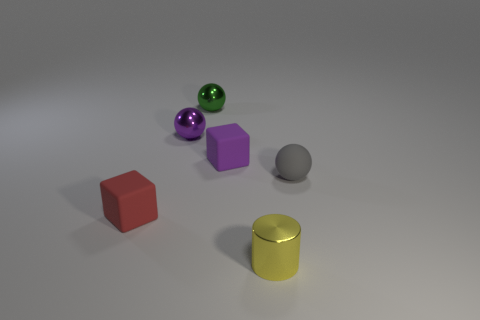Subtract all gray balls. How many balls are left? 2 Subtract all tiny purple metal balls. How many balls are left? 2 Add 2 small yellow matte objects. How many objects exist? 8 Subtract 1 cubes. How many cubes are left? 1 Subtract all cyan balls. Subtract all brown blocks. How many balls are left? 3 Subtract all yellow cylinders. How many red blocks are left? 1 Subtract all tiny metal cylinders. Subtract all small yellow things. How many objects are left? 4 Add 6 small matte cubes. How many small matte cubes are left? 8 Add 2 tiny purple spheres. How many tiny purple spheres exist? 3 Subtract 0 yellow blocks. How many objects are left? 6 